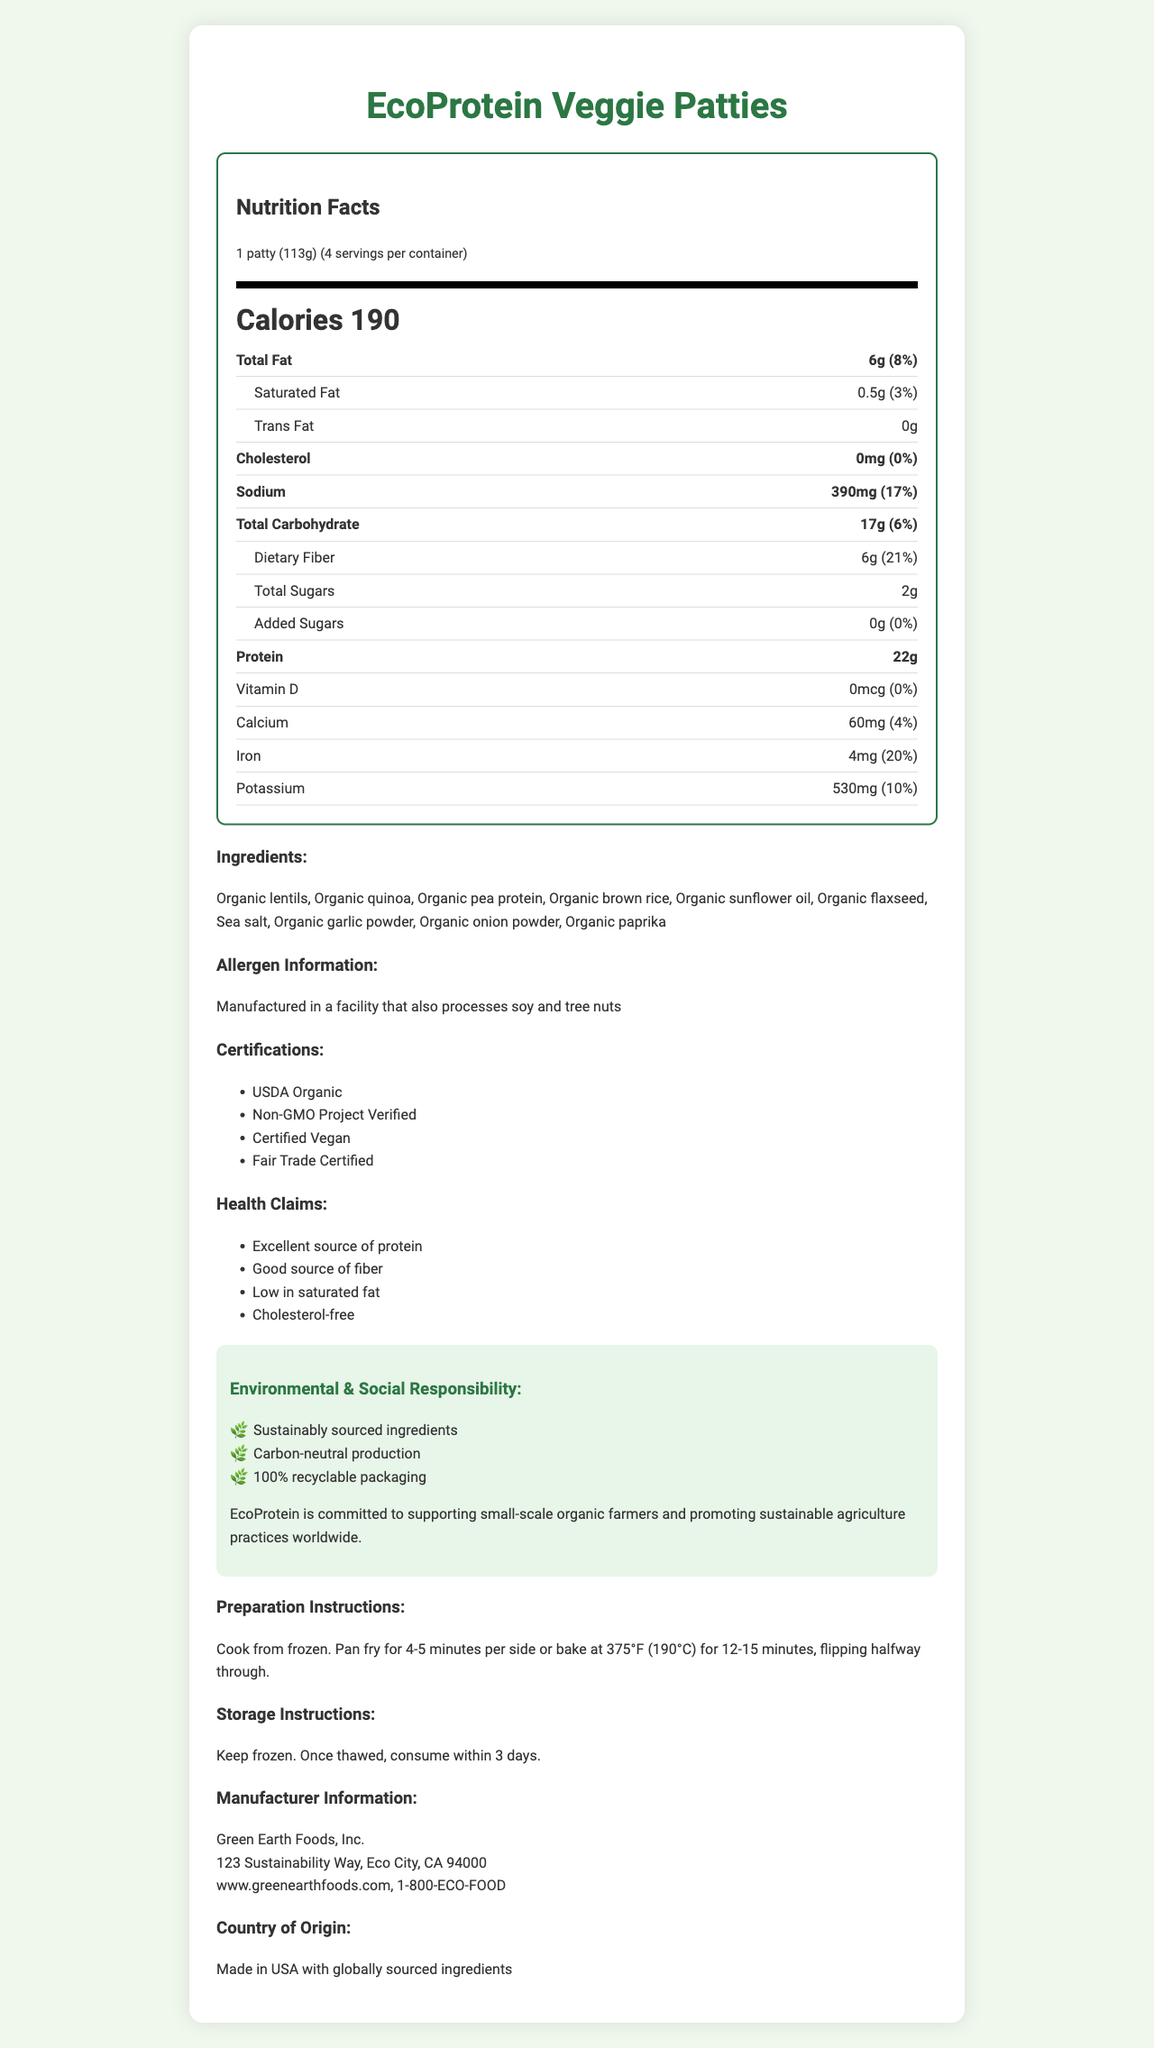what is the serving size? The serving size is explicitly stated in the nutrition facts section of the document.
Answer: 1 patty (113g) how many calories does one serving contain? This information is found at the beginning of the nutrition facts section under "Calories."
Answer: 190 how much protein is in each serving? The protein content per serving is listed in the nutrition facts section.
Answer: 22g how much total fat is in one serving? The total fat content per serving is listed under the "Total Fat" entry in the nutrition facts section.
Answer: 6g what is the amount of sodium per serving, in milligrams? The sodium content is specified in milligrams in the nutrition facts section.
Answer: 390mg which ingredient is NOT used in the EcoProtein Veggie Patties? A. Organic lentils B. Organic quinoa C. Organic coconut oil D. Organic sunflower oil Organic coconut oil is not listed as an ingredient in the ingredient list section.
Answer: C which of the following certifications does the product have? I. USDA Organic II. Non-GMO Project Verified III. Certified Vegan IV. Fair Trade Certified The product has all four certifications, as listed in the certifications section.
Answer: I, II, III, IV is the product gluten-free? The "Dietary Lifestyle Labels" section lists "Gluten-free."
Answer: Yes does the product contain any added sugars? The nutrition facts label shows 0g of added sugars.
Answer: No summarize the main idea of the document. The document outlines comprehensive information about EcoProtein Veggie Patties, aiming to inform consumers about its nutrition, ingredients, certifications, health benefits, and commitment to sustainability and social welfare.
Answer: The document provides an overview of the EcoProtein Veggie Patties, including detailed nutrition facts, ingredients, allergen information, certifications, health claims, environmental and social responsibility statements, preparation and storage instructions, manufacturer info, and country of origin. what is the source of the ingredients used in the product? The document does not specify the exact sources of the ingredients beyond mentioning that they are "globally sourced."
Answer: Not enough information how many servings are in one container? The serving information at the beginning of the nutrition facts section states that there are 4 servings per container.
Answer: 4 how much dietary fiber is in one serving, in grams? The dietary fiber content is listed in grams in the nutrition facts section.
Answer: 6g what are the preparation instructions for cooking the patties? The preparation instructions are provided towards the end of the document's main content sections.
Answer: Cook from frozen. Pan fry for 4-5 minutes per side or bake at 375°F (190°C) for 12-15 minutes, flipping halfway through. is the product cholesterol-free? The nutrition facts label specifies 0mg of cholesterol.
Answer: Yes how does the product support social welfare policies? The social responsibility statement explicitly mentions EcoProtein's commitment to these causes.
Answer: By supporting small-scale organic farmers and promoting sustainable agriculture practices worldwide 